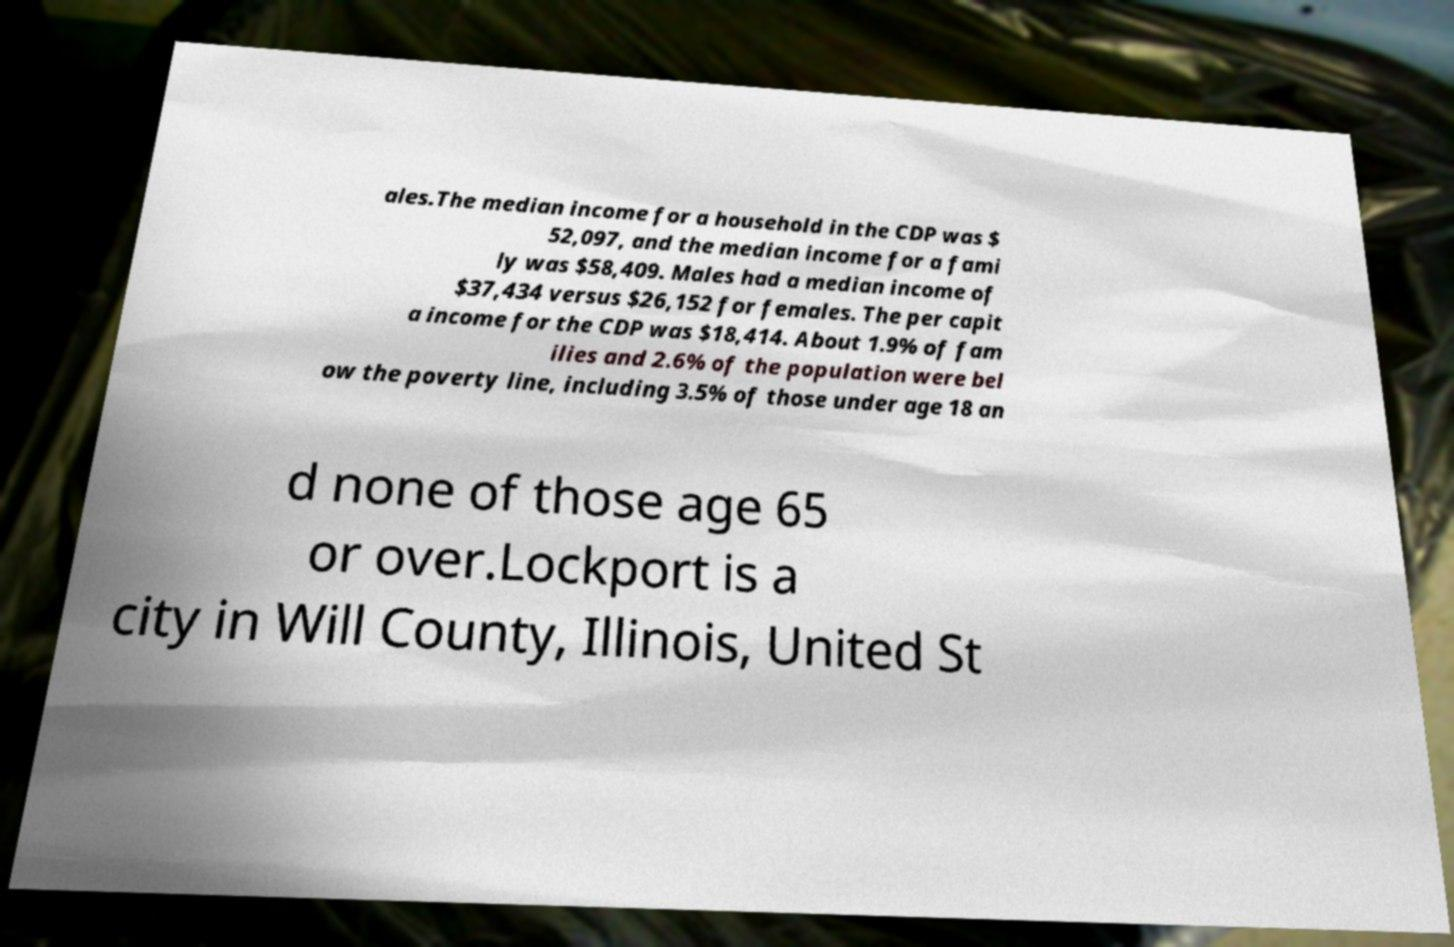There's text embedded in this image that I need extracted. Can you transcribe it verbatim? ales.The median income for a household in the CDP was $ 52,097, and the median income for a fami ly was $58,409. Males had a median income of $37,434 versus $26,152 for females. The per capit a income for the CDP was $18,414. About 1.9% of fam ilies and 2.6% of the population were bel ow the poverty line, including 3.5% of those under age 18 an d none of those age 65 or over.Lockport is a city in Will County, Illinois, United St 